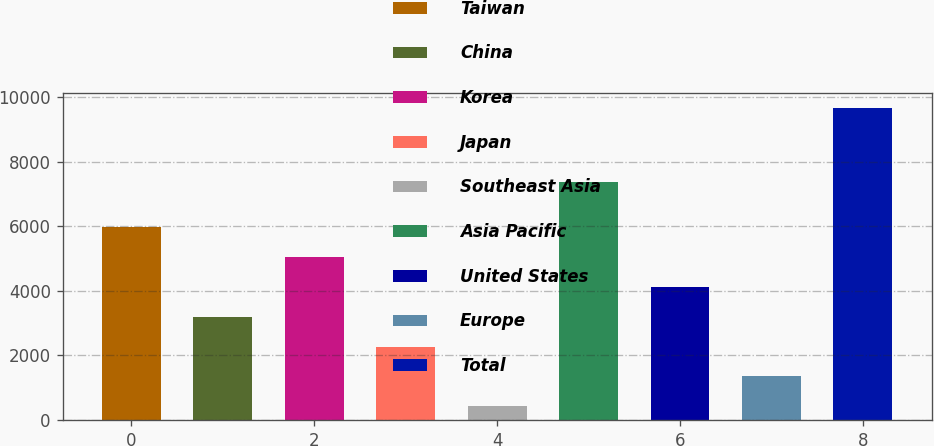<chart> <loc_0><loc_0><loc_500><loc_500><bar_chart><fcel>Taiwan<fcel>China<fcel>Korea<fcel>Japan<fcel>Southeast Asia<fcel>Asia Pacific<fcel>United States<fcel>Europe<fcel>Total<nl><fcel>5968.2<fcel>3200.1<fcel>5045.5<fcel>2277.4<fcel>432<fcel>7387<fcel>4122.8<fcel>1354.7<fcel>9659<nl></chart> 